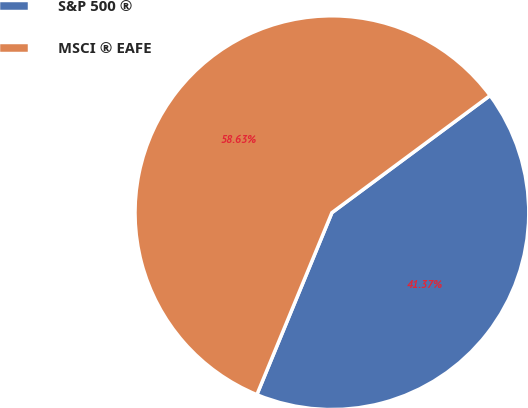<chart> <loc_0><loc_0><loc_500><loc_500><pie_chart><fcel>S&P 500 ®<fcel>MSCI ® EAFE<nl><fcel>41.37%<fcel>58.63%<nl></chart> 